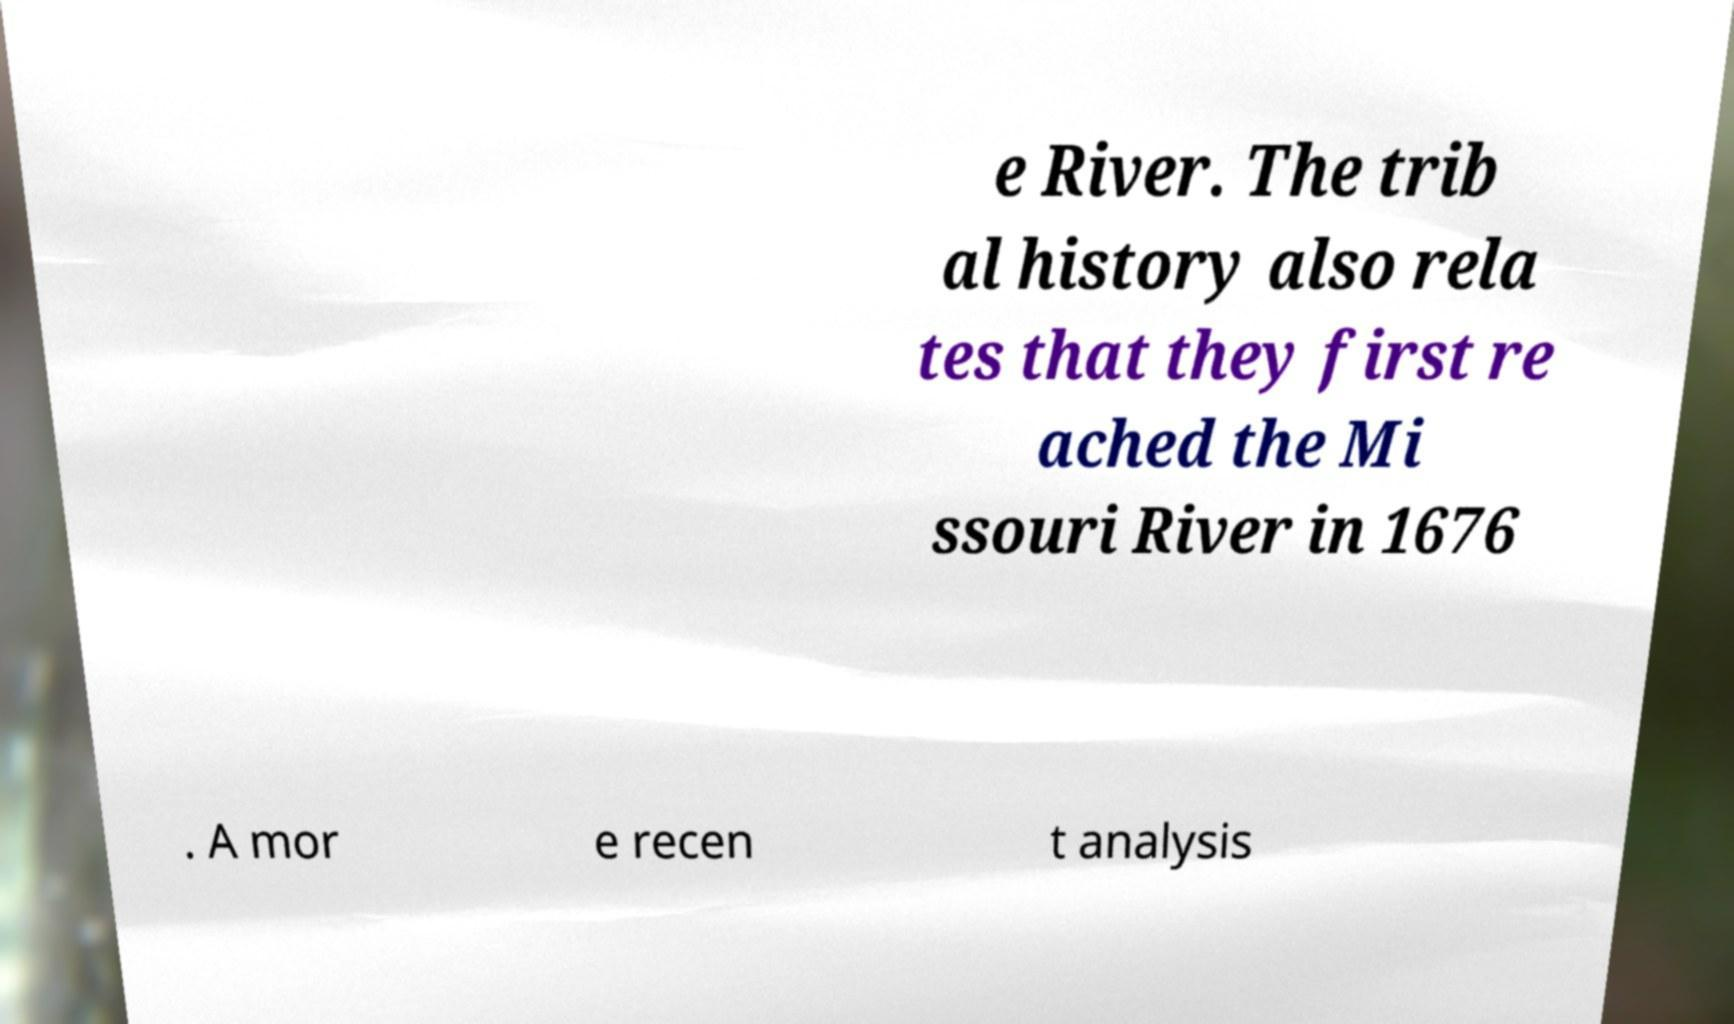Please identify and transcribe the text found in this image. e River. The trib al history also rela tes that they first re ached the Mi ssouri River in 1676 . A mor e recen t analysis 